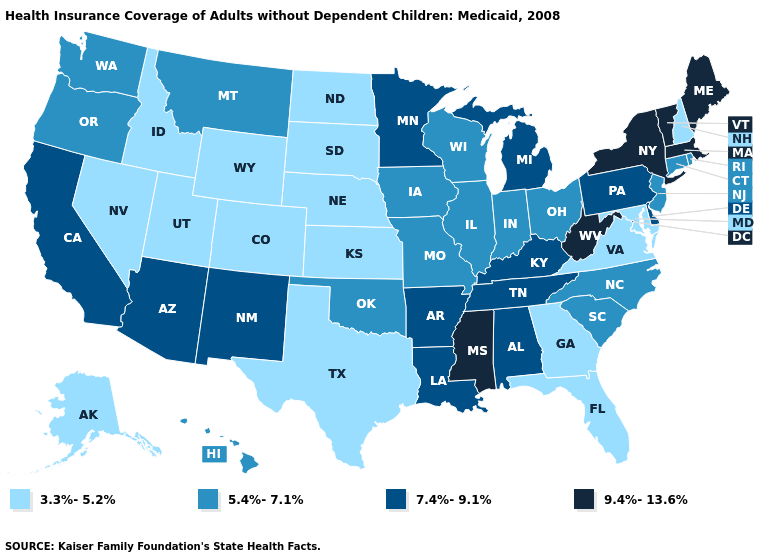What is the highest value in the USA?
Keep it brief. 9.4%-13.6%. What is the value of Ohio?
Keep it brief. 5.4%-7.1%. Name the states that have a value in the range 7.4%-9.1%?
Short answer required. Alabama, Arizona, Arkansas, California, Delaware, Kentucky, Louisiana, Michigan, Minnesota, New Mexico, Pennsylvania, Tennessee. Name the states that have a value in the range 9.4%-13.6%?
Keep it brief. Maine, Massachusetts, Mississippi, New York, Vermont, West Virginia. Name the states that have a value in the range 5.4%-7.1%?
Write a very short answer. Connecticut, Hawaii, Illinois, Indiana, Iowa, Missouri, Montana, New Jersey, North Carolina, Ohio, Oklahoma, Oregon, Rhode Island, South Carolina, Washington, Wisconsin. Does Rhode Island have the lowest value in the USA?
Concise answer only. No. Does Massachusetts have a lower value than New Jersey?
Give a very brief answer. No. What is the value of Oregon?
Give a very brief answer. 5.4%-7.1%. What is the value of South Dakota?
Short answer required. 3.3%-5.2%. What is the value of Maine?
Answer briefly. 9.4%-13.6%. Does South Carolina have a lower value than Georgia?
Keep it brief. No. What is the lowest value in the USA?
Quick response, please. 3.3%-5.2%. What is the value of Tennessee?
Short answer required. 7.4%-9.1%. Name the states that have a value in the range 9.4%-13.6%?
Quick response, please. Maine, Massachusetts, Mississippi, New York, Vermont, West Virginia. What is the value of North Dakota?
Write a very short answer. 3.3%-5.2%. 